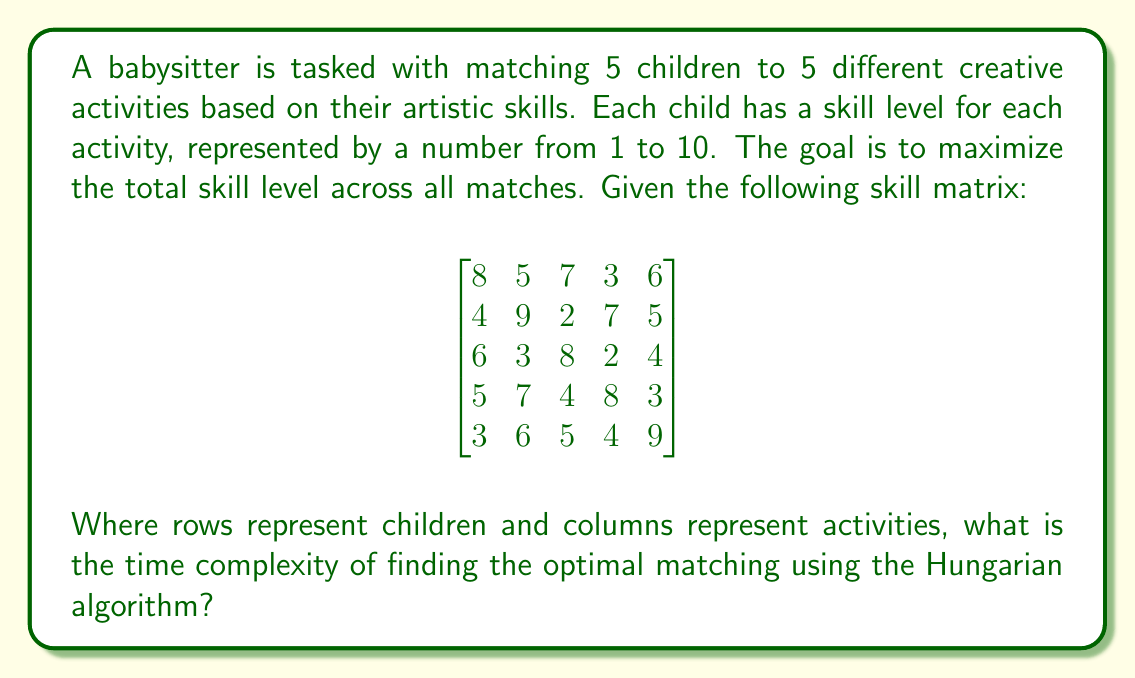What is the answer to this math problem? To solve this problem, we need to understand the Hungarian algorithm and its time complexity:

1. The Hungarian algorithm is used for solving the assignment problem, which in this case is matching children to activities optimally.

2. For a square matrix of size $n \times n$, the time complexity of the Hungarian algorithm is $O(n^3)$.

3. In our case, we have a 5x5 matrix, so $n = 5$.

4. The algorithm works by performing a series of matrix operations, including finding a zero in each row and column, and potentially adjusting the matrix values.

5. These operations are repeated until an optimal assignment is found.

6. The cubic time complexity comes from the fact that in the worst case, we might need to perform $O(n)$ iterations, each involving $O(n^2)$ operations.

7. It's important to note that while there are $5! = 120$ possible assignments, the Hungarian algorithm finds the optimal solution much more efficiently than checking all possibilities.

8. For the freelance artist, this means that even as the number of children and activities grows, the babysitter can efficiently match them to maximize their engagement and skill development.

Therefore, the time complexity for this 5x5 matrix using the Hungarian algorithm is $O(5^3) = O(125)$, which is considered polynomial time and thus efficient for this size of problem.
Answer: $O(n^3)$, where $n$ is the number of children/activities (in this case, $n=5$) 